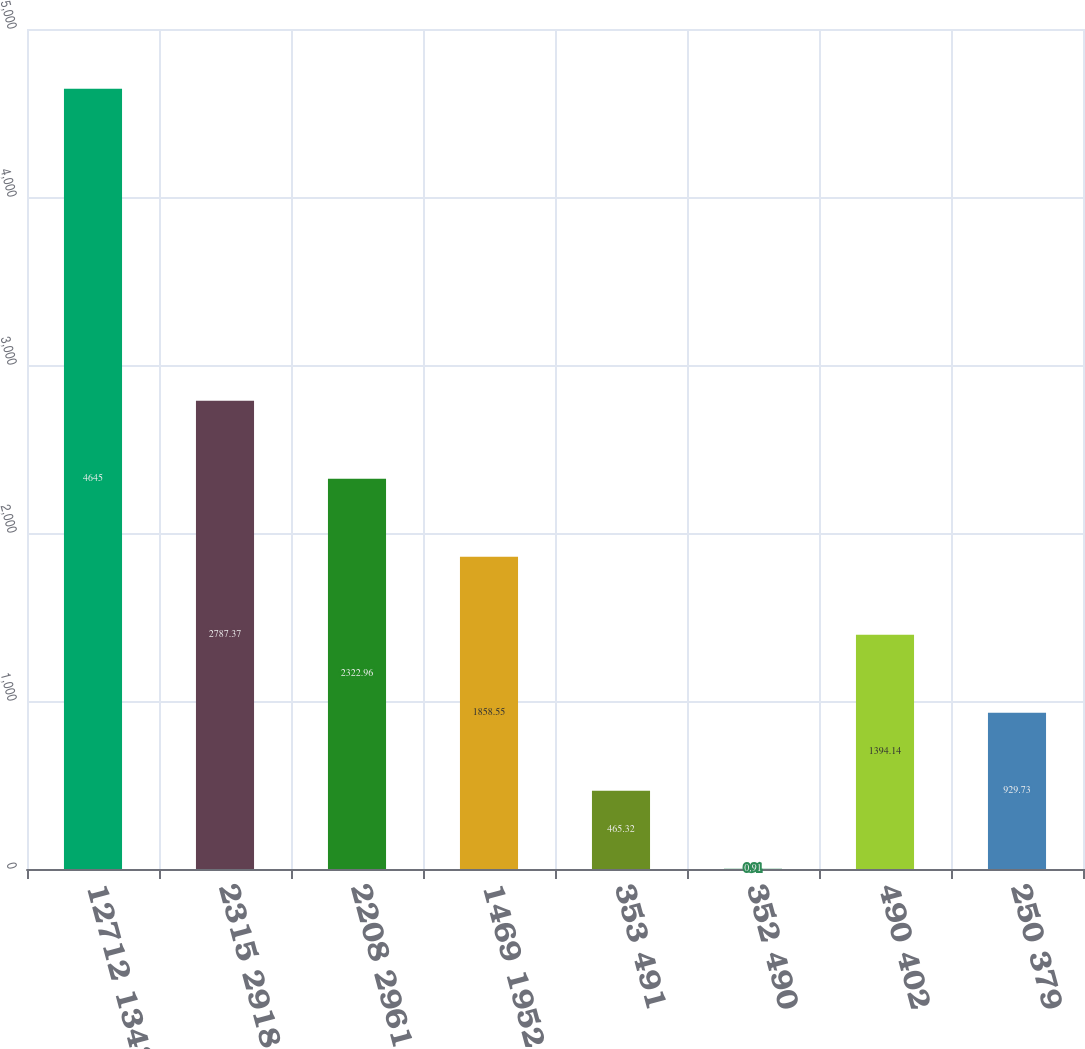Convert chart to OTSL. <chart><loc_0><loc_0><loc_500><loc_500><bar_chart><fcel>12712 13431<fcel>2315 2918<fcel>2208 2961<fcel>1469 1952<fcel>353 491<fcel>352 490<fcel>490 402<fcel>250 379<nl><fcel>4645<fcel>2787.37<fcel>2322.96<fcel>1858.55<fcel>465.32<fcel>0.91<fcel>1394.14<fcel>929.73<nl></chart> 